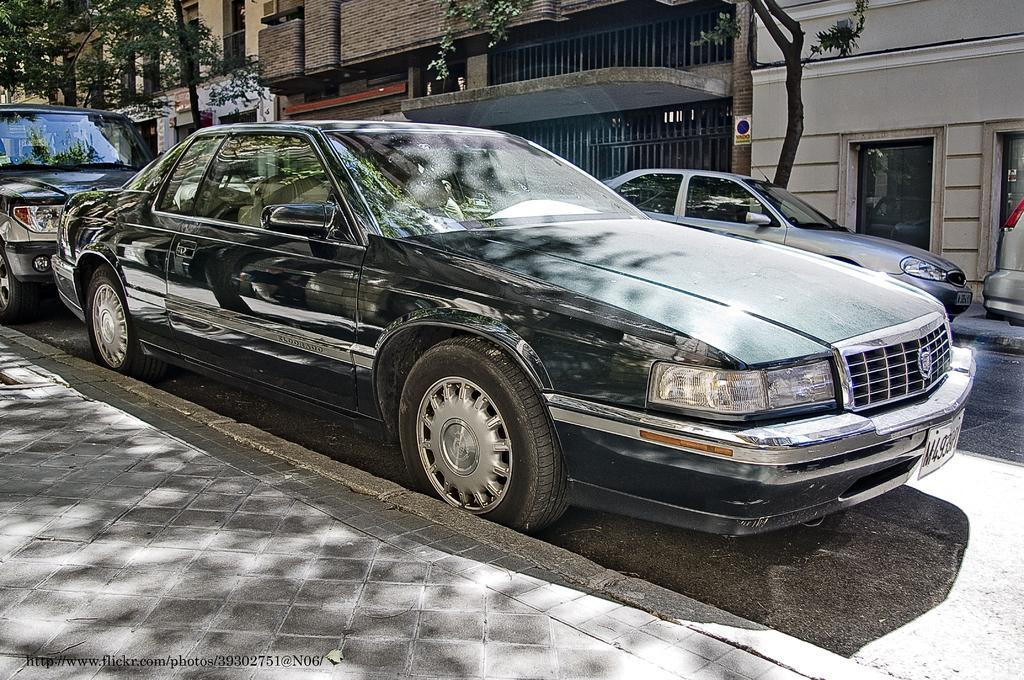Can you describe this image briefly? In the center of the image we can see cars, buildings, trees, windows, door, grills. At the bottom of the image we can see road, some text. 